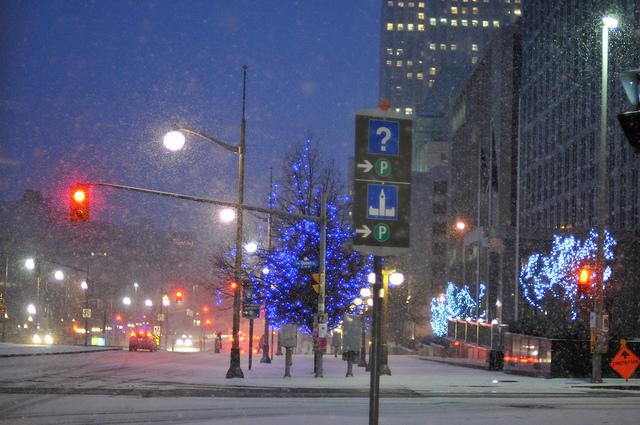Why have they made the trees blue? christmas 